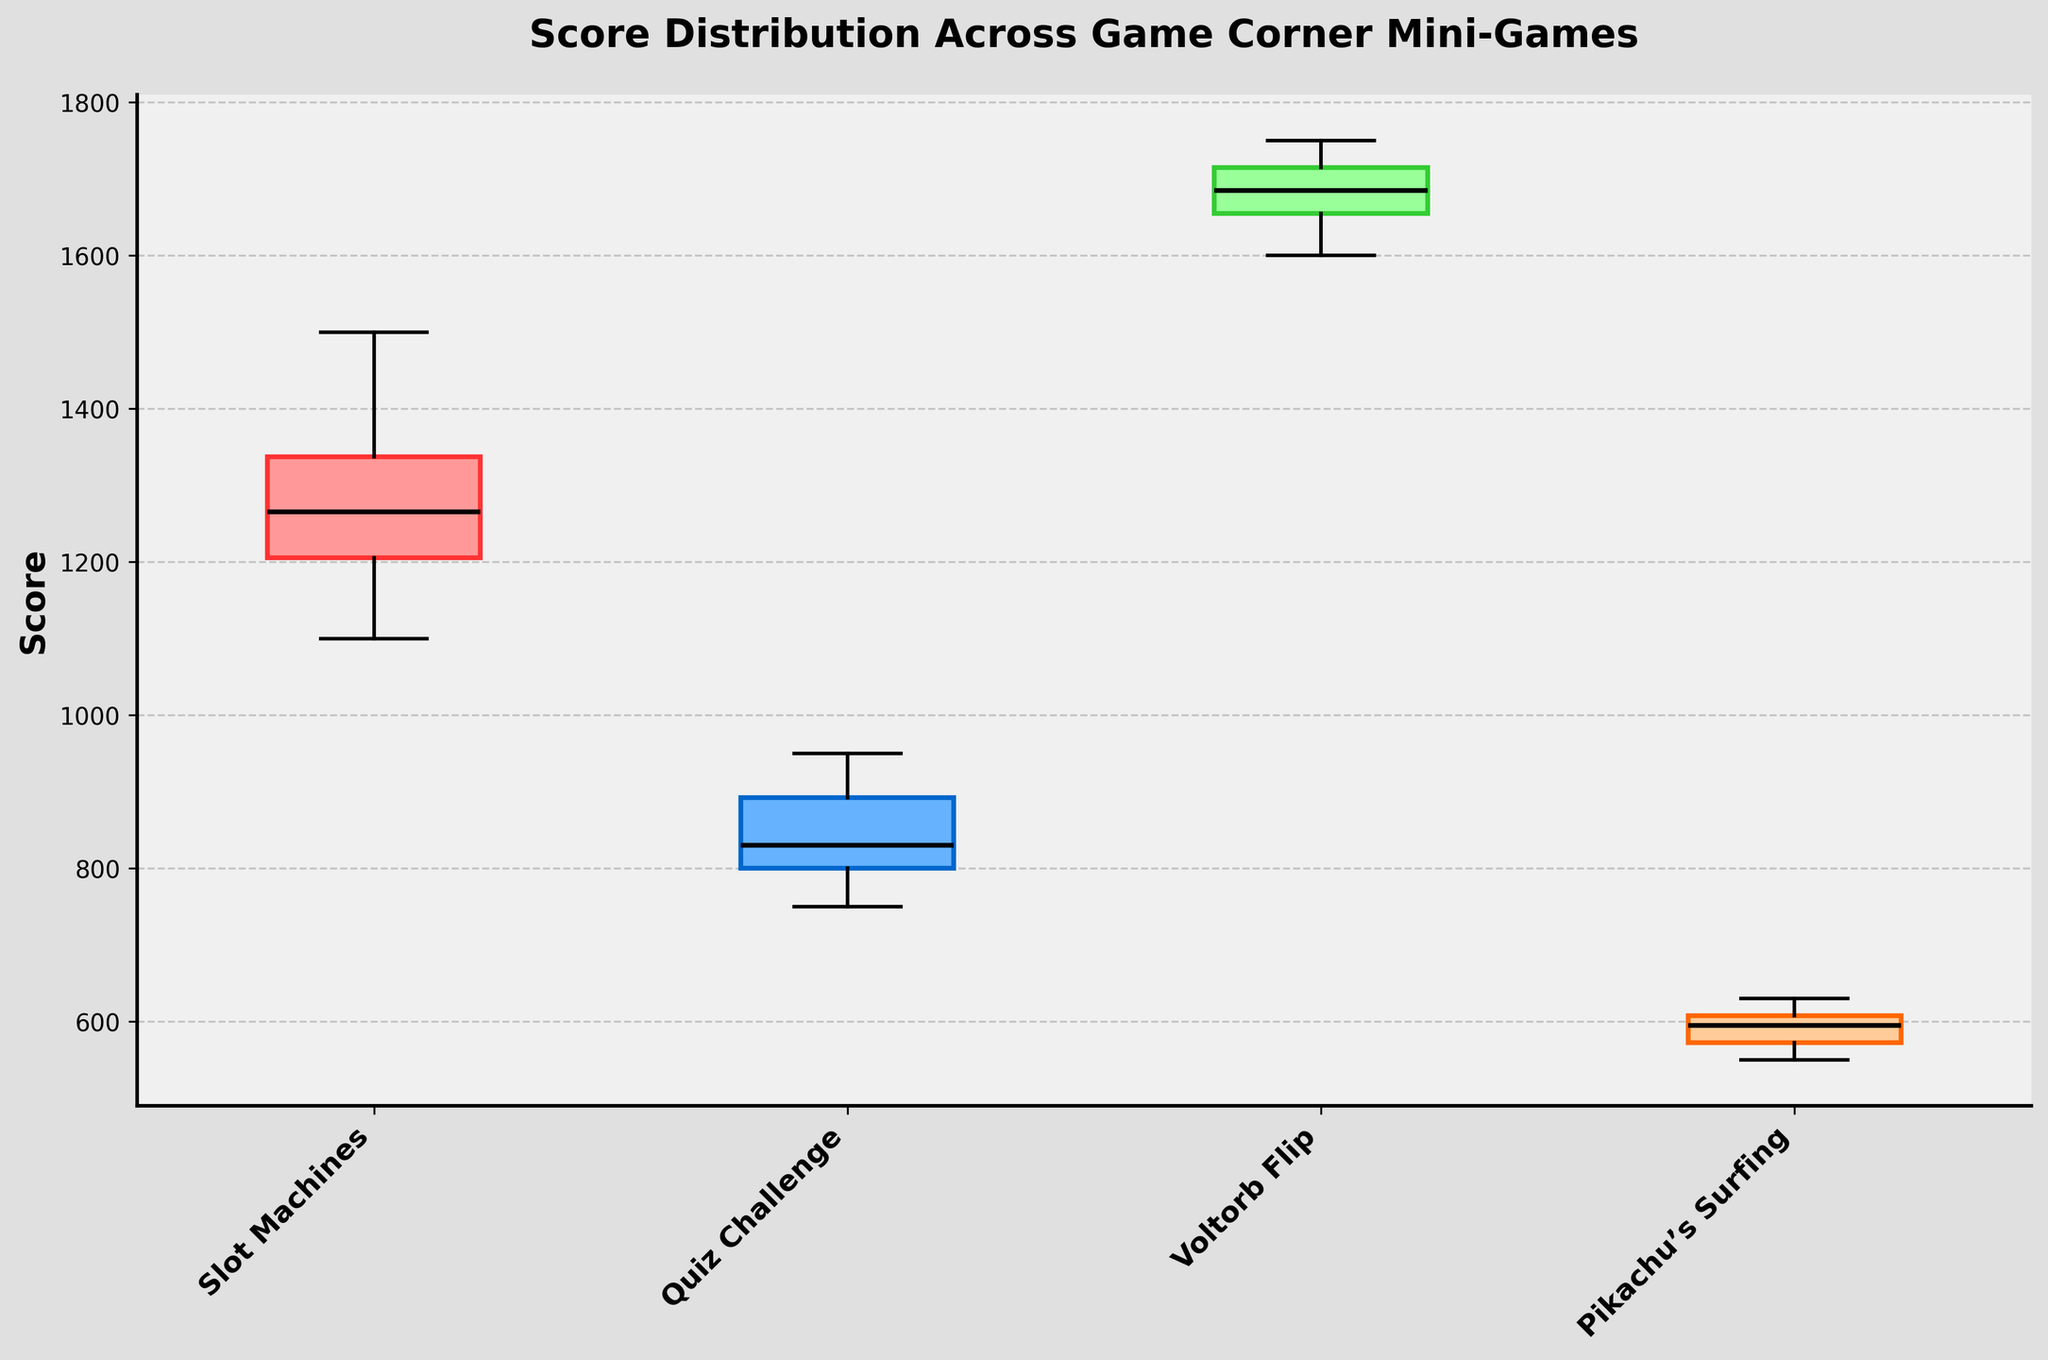What's the title of the figure? The title is displayed at the top of the figure, indicating the primary subject of the visual data representation.
Answer: Score Distribution Across Game Corner Mini-Games What is the median score for Voltorb Flip? On a box plot, the median is indicated by the line inside the box. Locate the box corresponding to Voltorb Flip and find the value of the median line.
Answer: 1680 Which mini-game shows the highest median score? Compare the median lines (the lines inside the boxes) of all the mini-games and identify the highest one.
Answer: Voltorb Flip What is the interquartile range (IQR) for Slot Machines? The IQR is the distance between the lower quartile (Q1) and the upper quartile (Q3). Measure the length between the bottom and top edges of the Slot Machines’ box.
Answer: 150 Which mini-game displays the widest range between the minimum and maximum scores? The range is depicted by the distance between the bottom whisker and the top whisker for each box. Identify the box plot with the widest whiskers.
Answer: Voltorb Flip What are the colors used for the boxes representing each mini-game? The colors of the boxes can be visually observed. List the color of each box in sequential order of the mini-games.
Answer: Slot Machines: Light Red, Quiz Challenge: Light Blue, Voltorb Flip: Light Green, Pikachu’s Surfing: Light Orange Is there any overlap in the score distribution of Quiz Challenge and Slot Machines? Overlap occurs if the range (whiskers) or boxes of the two games intersect each other on the plot. Check if the whiskers or boxes of Quiz Challenge and Slot Machines intersect.
Answer: Yes Which mini-game has the most consistent scores based on the box plot? Consistency is shown by a smaller box and shorter whiskers, indicating less variability. Identify the box plot with the smallest box and shortest whiskers.
Answer: Pikachu’s Surfing Compare the median scores of Quiz Challenge and Pikachu’s Surfing. Which has a lower median? Locate the median lines of both games and compare their numerical values. The lower value indicates the lower median score.
Answer: Pikachu’s Surfing 